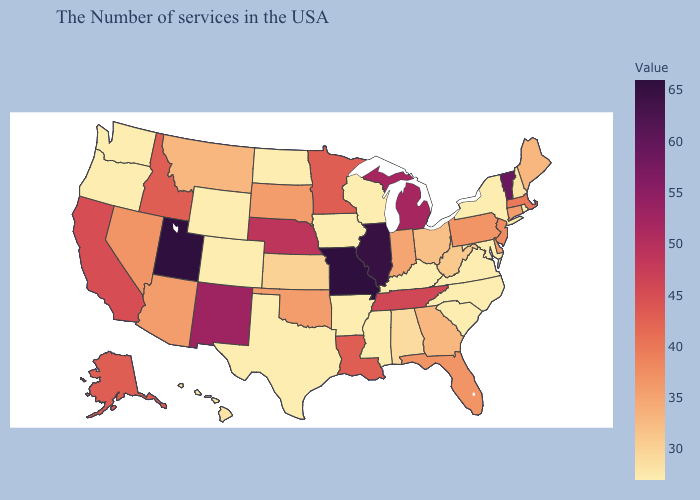Does Rhode Island have the lowest value in the Northeast?
Answer briefly. Yes. Does Kansas have the lowest value in the USA?
Quick response, please. No. Among the states that border Idaho , which have the highest value?
Keep it brief. Utah. Does Oregon have the highest value in the USA?
Quick response, please. No. 